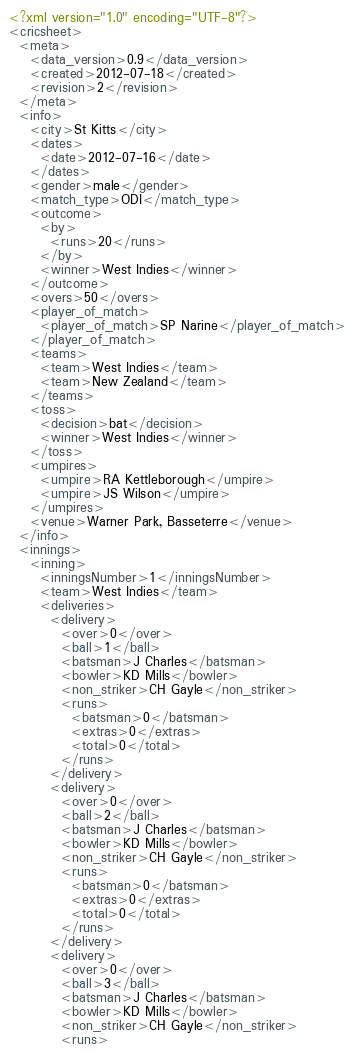<code> <loc_0><loc_0><loc_500><loc_500><_XML_><?xml version="1.0" encoding="UTF-8"?>
<cricsheet>
  <meta>
    <data_version>0.9</data_version>
    <created>2012-07-18</created>
    <revision>2</revision>
  </meta>
  <info>
    <city>St Kitts</city>
    <dates>
      <date>2012-07-16</date>
    </dates>
    <gender>male</gender>
    <match_type>ODI</match_type>
    <outcome>
      <by>
        <runs>20</runs>
      </by>
      <winner>West Indies</winner>
    </outcome>
    <overs>50</overs>
    <player_of_match>
      <player_of_match>SP Narine</player_of_match>
    </player_of_match>
    <teams>
      <team>West Indies</team>
      <team>New Zealand</team>
    </teams>
    <toss>
      <decision>bat</decision>
      <winner>West Indies</winner>
    </toss>
    <umpires>
      <umpire>RA Kettleborough</umpire>
      <umpire>JS Wilson</umpire>
    </umpires>
    <venue>Warner Park, Basseterre</venue>
  </info>
  <innings>
    <inning>
      <inningsNumber>1</inningsNumber>
      <team>West Indies</team>
      <deliveries>
        <delivery>
          <over>0</over>
          <ball>1</ball>
          <batsman>J Charles</batsman>
          <bowler>KD Mills</bowler>
          <non_striker>CH Gayle</non_striker>
          <runs>
            <batsman>0</batsman>
            <extras>0</extras>
            <total>0</total>
          </runs>
        </delivery>
        <delivery>
          <over>0</over>
          <ball>2</ball>
          <batsman>J Charles</batsman>
          <bowler>KD Mills</bowler>
          <non_striker>CH Gayle</non_striker>
          <runs>
            <batsman>0</batsman>
            <extras>0</extras>
            <total>0</total>
          </runs>
        </delivery>
        <delivery>
          <over>0</over>
          <ball>3</ball>
          <batsman>J Charles</batsman>
          <bowler>KD Mills</bowler>
          <non_striker>CH Gayle</non_striker>
          <runs></code> 